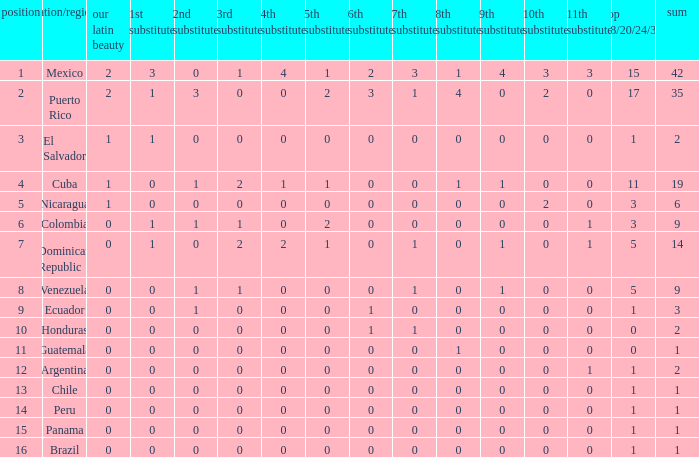What is the total number of 3rd runners-up of the country ranked lower than 12 with a 10th runner-up of 0, an 8th runner-up less than 1, and a 7th runner-up of 0? 4.0. 